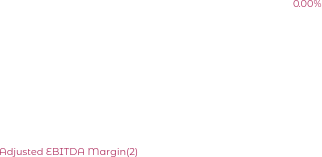<chart> <loc_0><loc_0><loc_500><loc_500><pie_chart><fcel>Adjusted EBITDA(2)<fcel>Adjusted EBITDA Margin(2)<nl><fcel>100.0%<fcel>0.0%<nl></chart> 